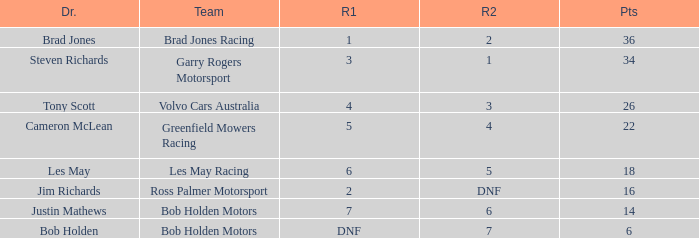Which driver for Greenfield Mowers Racing has fewer than 36 points? Cameron McLean. 